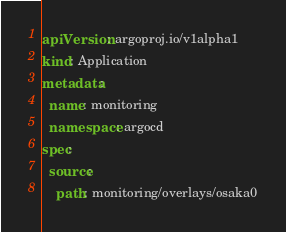Convert code to text. <code><loc_0><loc_0><loc_500><loc_500><_YAML_>apiVersion: argoproj.io/v1alpha1
kind: Application
metadata:
  name: monitoring
  namespace: argocd
spec:
  source:
    path: monitoring/overlays/osaka0
</code> 